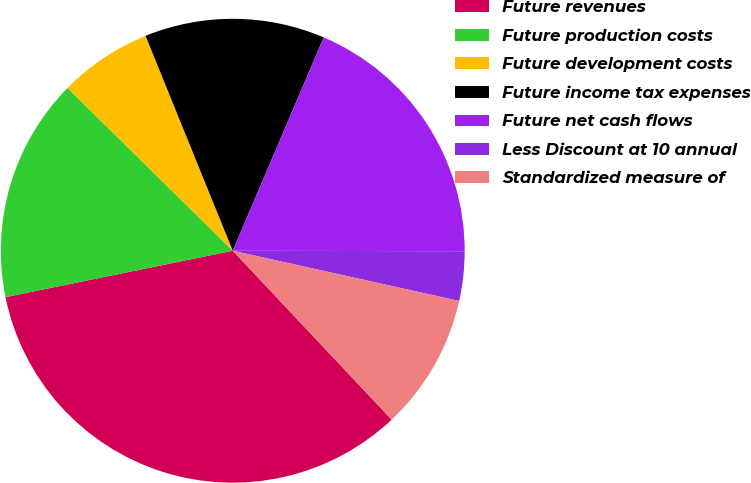Convert chart. <chart><loc_0><loc_0><loc_500><loc_500><pie_chart><fcel>Future revenues<fcel>Future production costs<fcel>Future development costs<fcel>Future income tax expenses<fcel>Future net cash flows<fcel>Less Discount at 10 annual<fcel>Standardized measure of<nl><fcel>33.81%<fcel>15.59%<fcel>6.48%<fcel>12.55%<fcel>18.62%<fcel>3.44%<fcel>9.51%<nl></chart> 